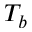<formula> <loc_0><loc_0><loc_500><loc_500>T _ { b }</formula> 